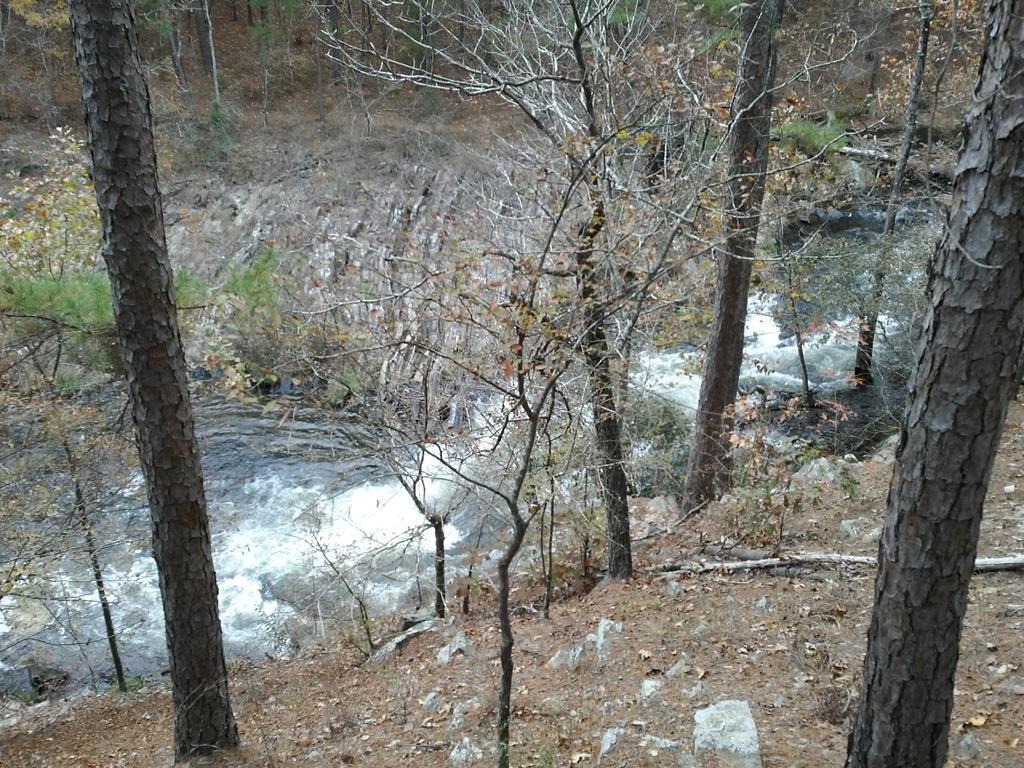Describe this image in one or two sentences. In this image I can see few dried tree and few trees in green color and I can see few stones. 